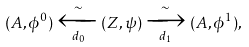Convert formula to latex. <formula><loc_0><loc_0><loc_500><loc_500>( A , \phi ^ { 0 } ) \xleftarrow [ d _ { 0 } ] { \sim } ( Z , \psi ) \xrightarrow [ d _ { 1 } ] { \sim } ( A , \phi ^ { 1 } ) ,</formula> 